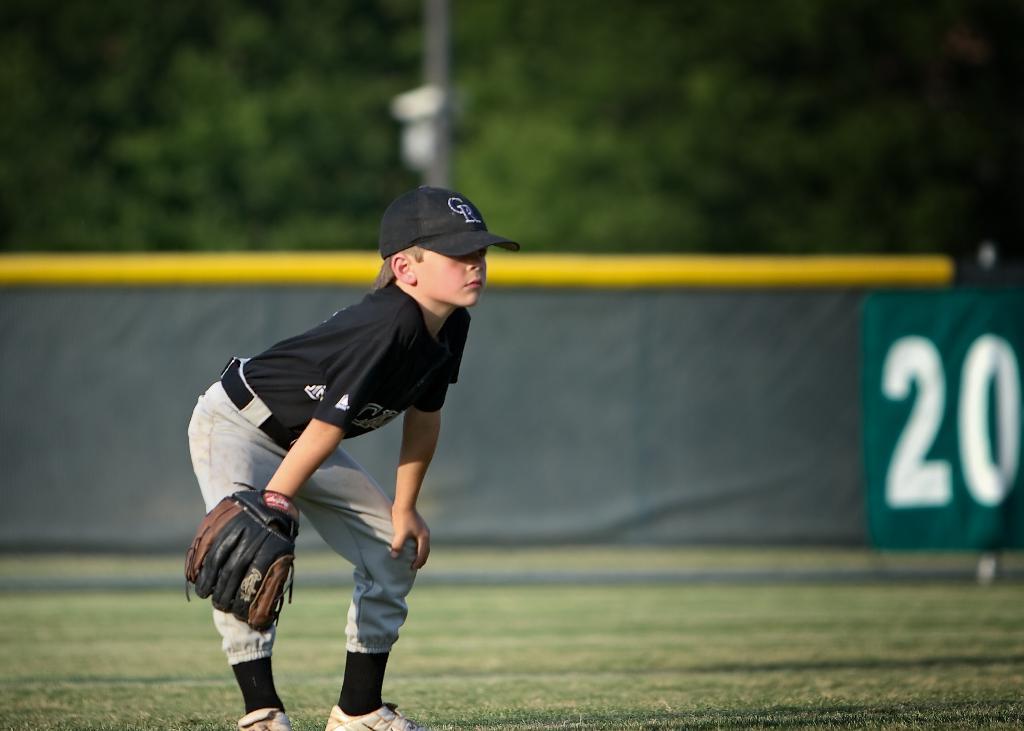What letters comprise the logo on the player'?
Your answer should be very brief. Cr. 